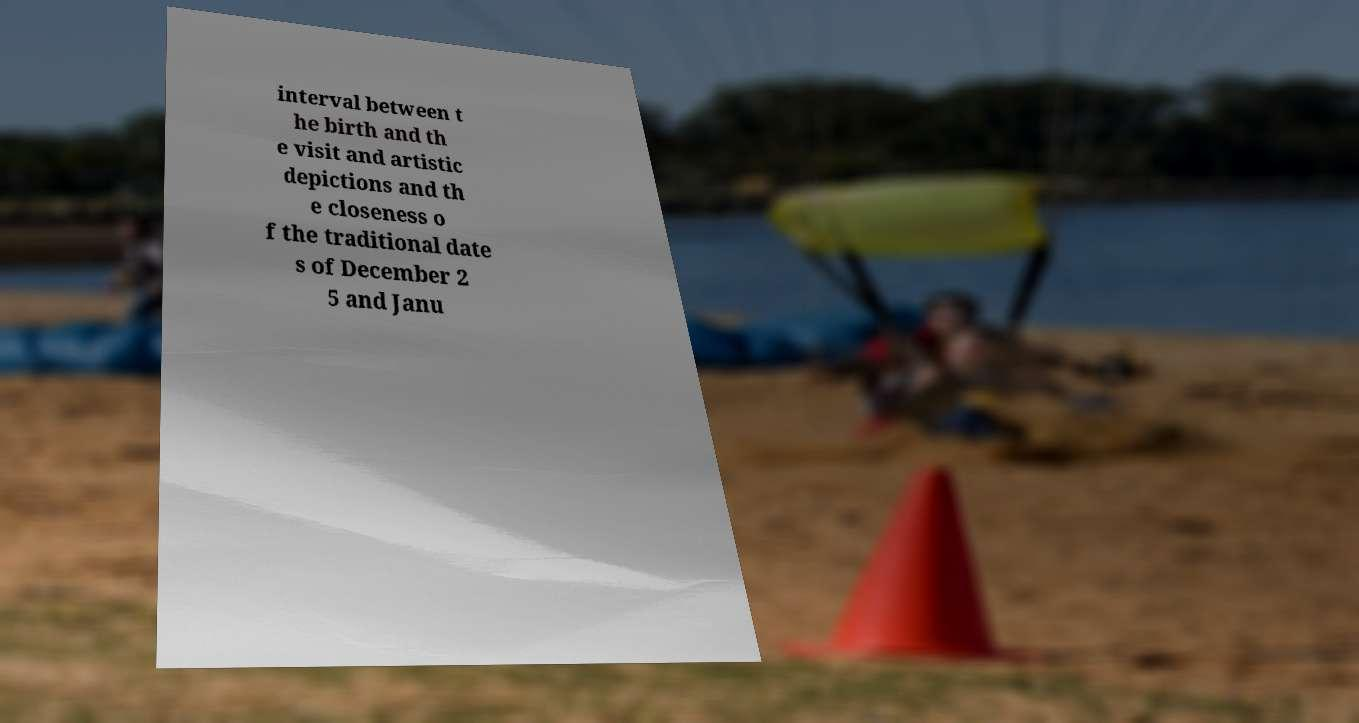Can you read and provide the text displayed in the image?This photo seems to have some interesting text. Can you extract and type it out for me? interval between t he birth and th e visit and artistic depictions and th e closeness o f the traditional date s of December 2 5 and Janu 